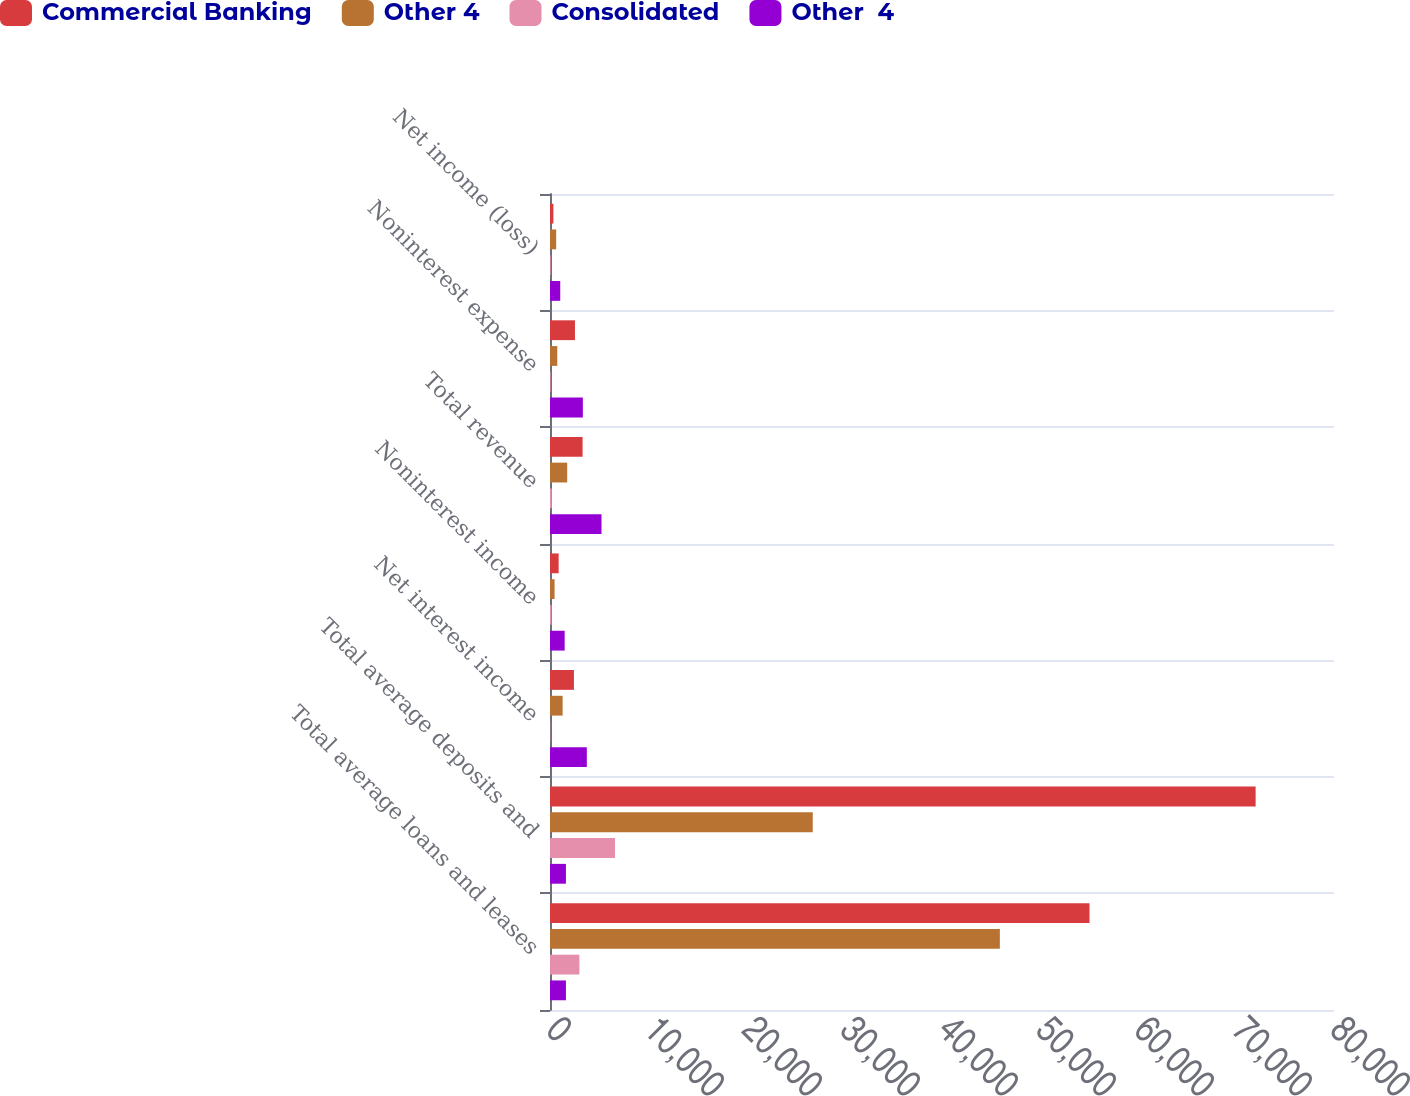Convert chart. <chart><loc_0><loc_0><loc_500><loc_500><stacked_bar_chart><ecel><fcel>Total average loans and leases<fcel>Total average deposits and<fcel>Net interest income<fcel>Noninterest income<fcel>Total revenue<fcel>Noninterest expense<fcel>Net income (loss)<nl><fcel>Commercial Banking<fcel>55052<fcel>72003<fcel>2443<fcel>883<fcel>3326<fcel>2547<fcel>345<nl><fcel>Other 4<fcel>45903<fcel>26811<fcel>1288<fcel>466<fcel>1754<fcel>741<fcel>631<nl><fcel>Consolidated<fcel>2999<fcel>6633<fcel>27<fcel>148<fcel>175<fcel>64<fcel>69<nl><fcel>Other  4<fcel>1625.5<fcel>1625.5<fcel>3758<fcel>1497<fcel>5255<fcel>3352<fcel>1045<nl></chart> 